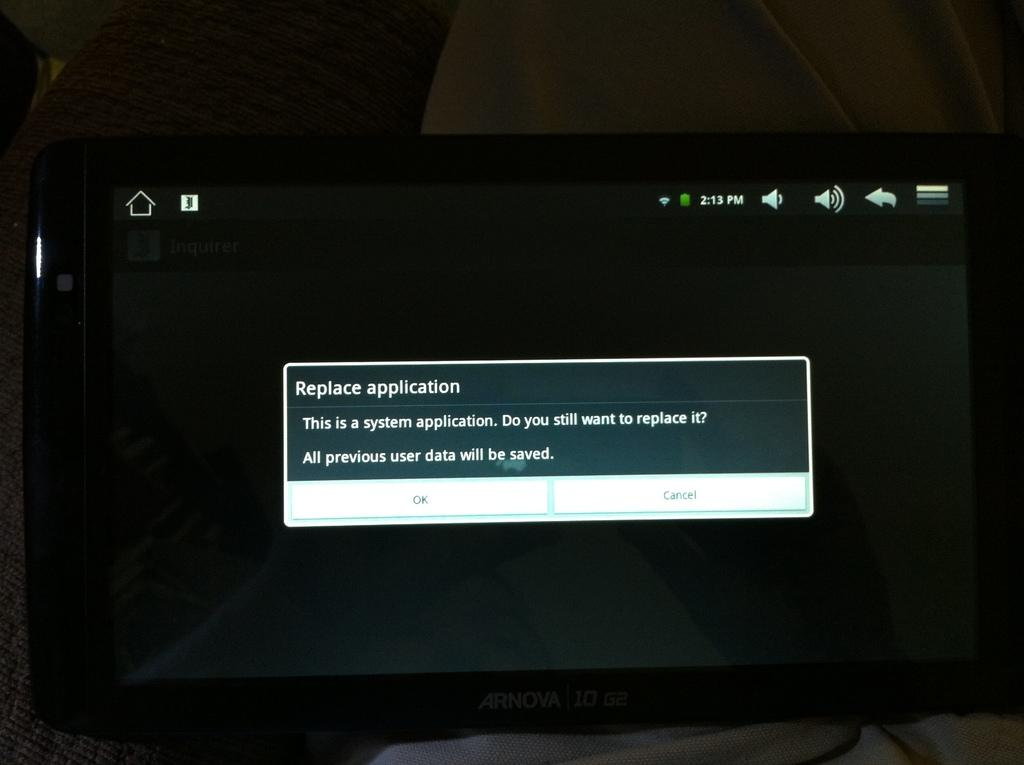<image>
Render a clear and concise summary of the photo. An Arnova tablet displays a pop up titled Replace application. 